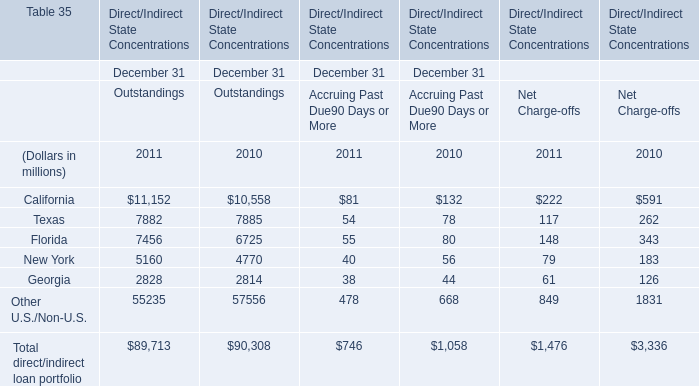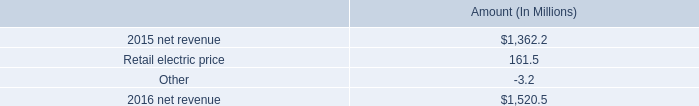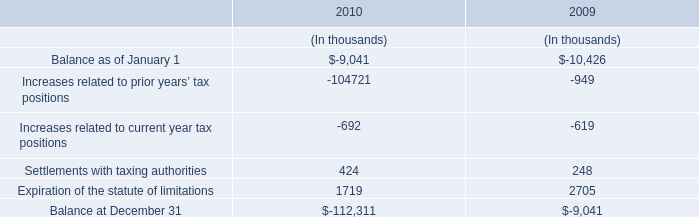Which year is New York in Outstandings the most? 
Answer: 2011. 